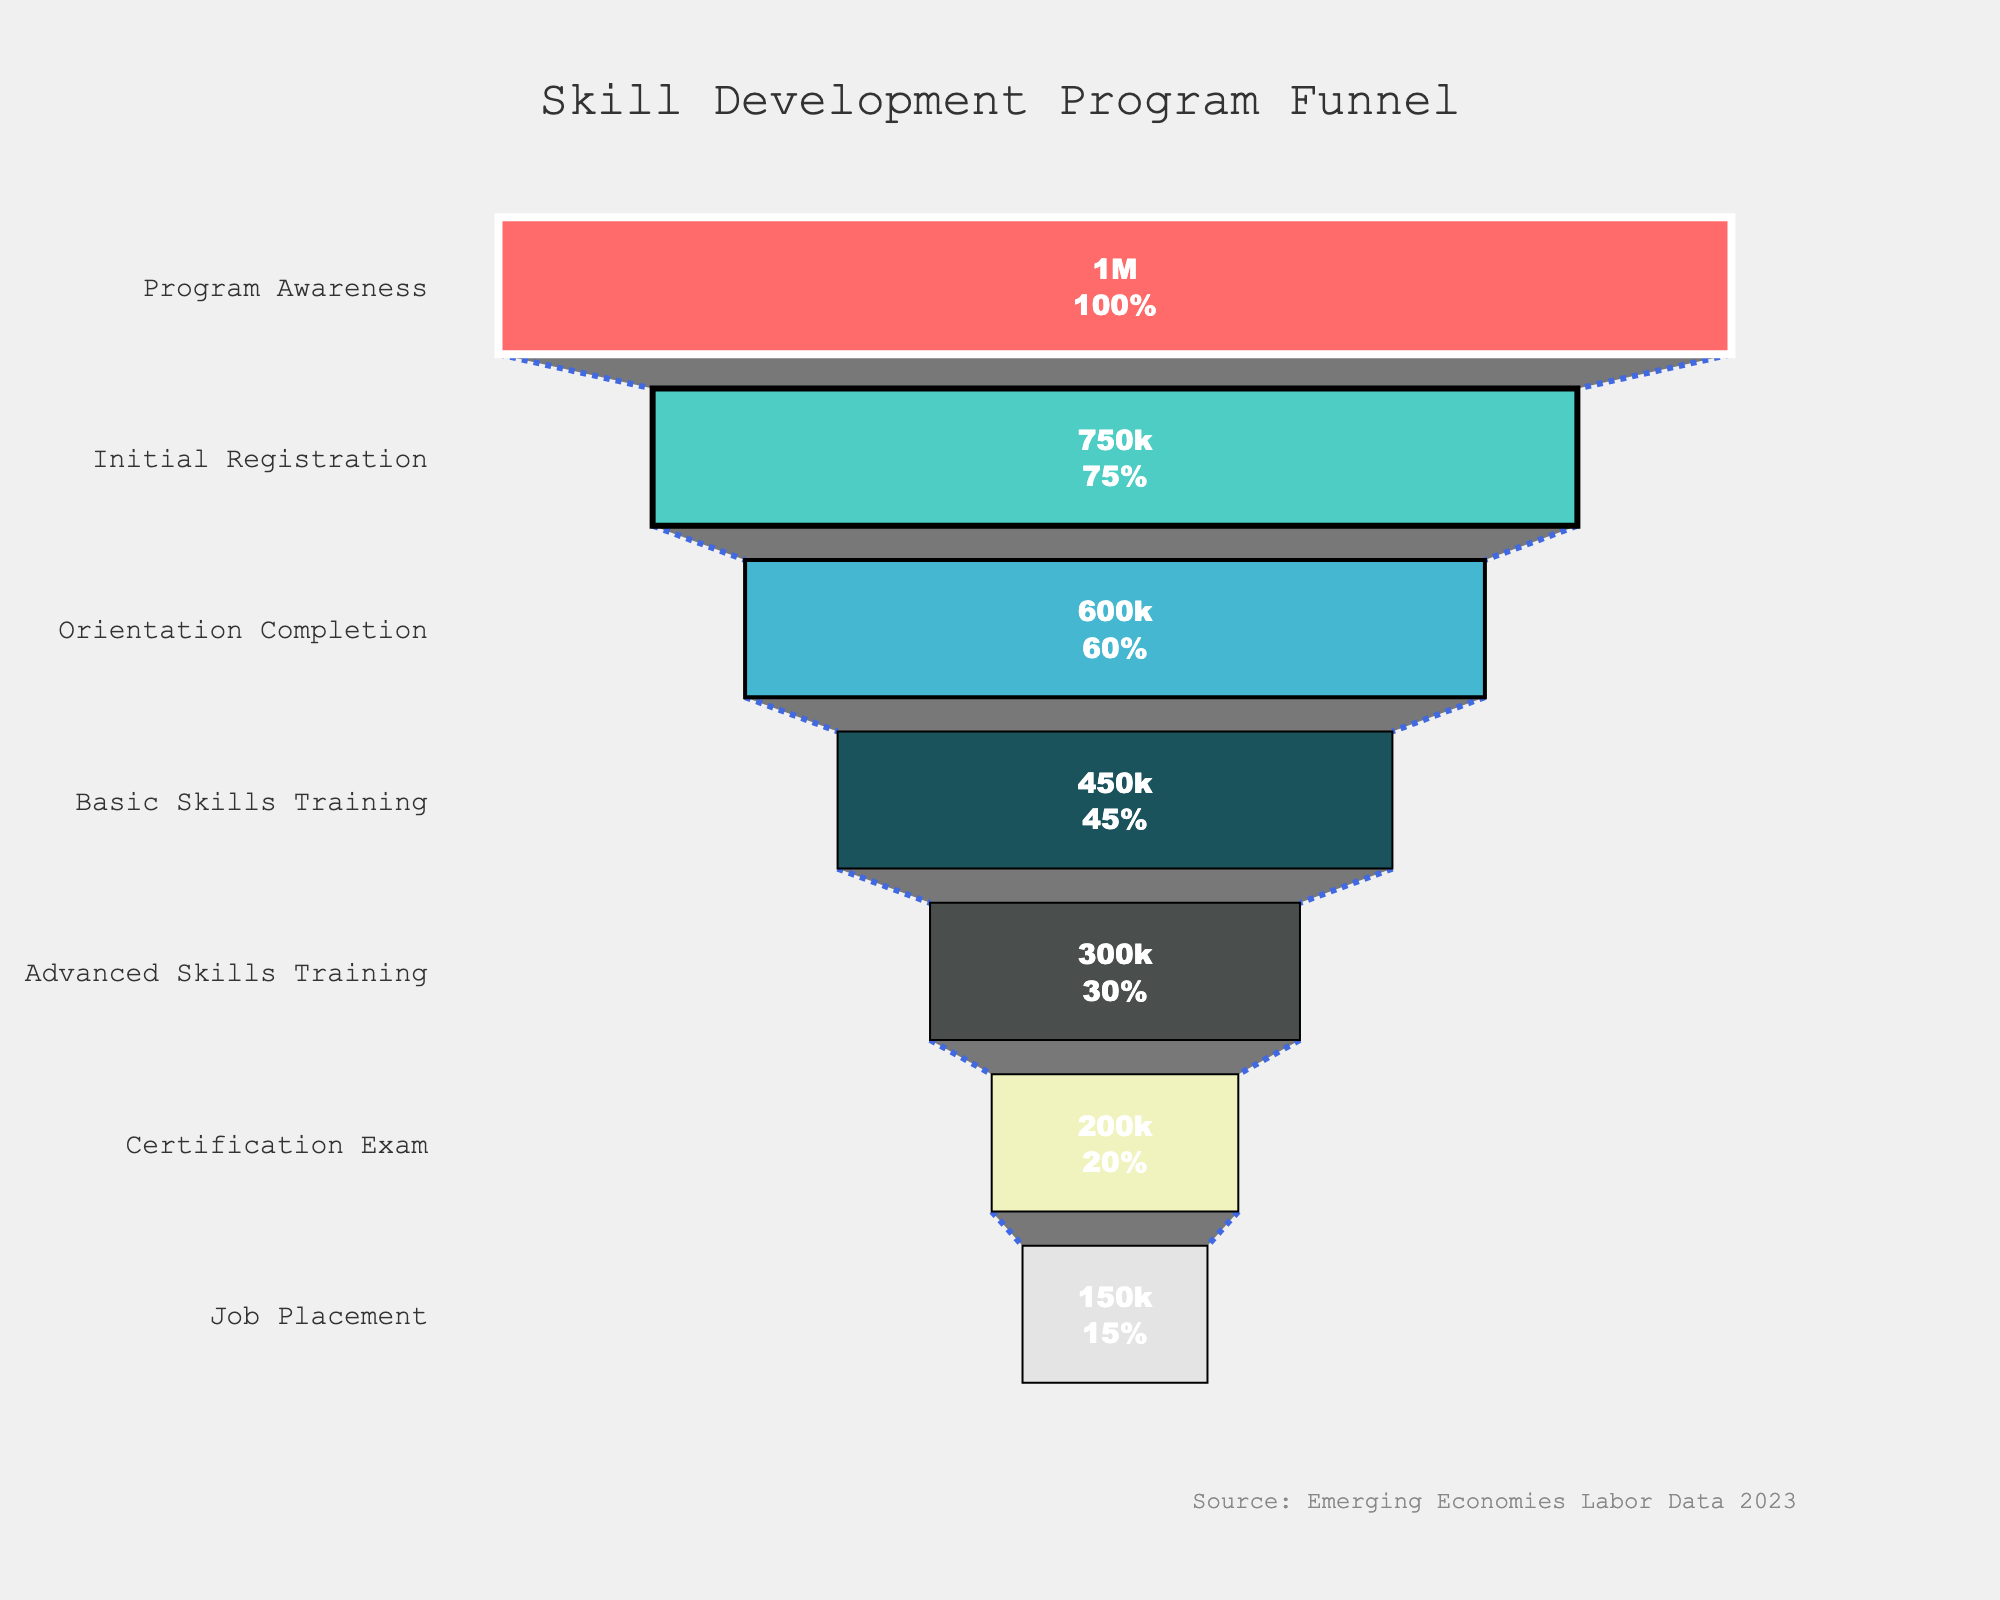What's the title of the chart? The title of the chart is given at the top of the figure. By observing the figure, we can see that the title is clearly labeled as "Skill Development Program Funnel".
Answer: Skill Development Program Funnel How many stages are there in the funnel chart? By examining the different sections in the funnel chart, we can count the number of labeled stages. The total count of these sections gives us the number of stages in the funnel.
Answer: 7 What stage has the highest number of participants? The stage with the highest number of participants is the widest bar at the top of the funnel. The width represents the number of participants. The topmost and the widest bar is labeled "Program Awareness".
Answer: Program Awareness How many participants completed the Certification Exam? The figure shows the number of participants for each stage on the bars. By referring to the "Certification Exam" stage, we can see the number labeled inside the bar.
Answer: 200,000 What is the difference in the number of participants between Advanced Skills Training and Job Placement? We need to subtract the number of participants at the "Job Placement" stage from the number at the "Advanced Skills Training" stage. This gives us 300,000 - 150,000.
Answer: 150,000 Which stage has the lowest retention rate compared to the previous stage? To determine the lowest retention rate, we need to find the stage with the largest drop in participant numbers compared to the previous stage. The difference is found by comparing the participant numbers for consecutive stages.
Answer: Advanced Skills Training to Certification Exam What percentage of initial registrations completed the job placement? We need to divide the number of participants in the "Job Placement" stage by the number of participants in the "Initial Registration" stage and then multiply by 100 to get the percentage: (150,000 / 750,000) * 100.
Answer: 20% How many participants completed the initial registration but did not move on to orientation? The number of participants can be found by subtracting the number of participants who completed the "Orientation Completion" stage from those who completed the "Initial Registration" stage: 750,000 - 600,000.
Answer: 150,000 